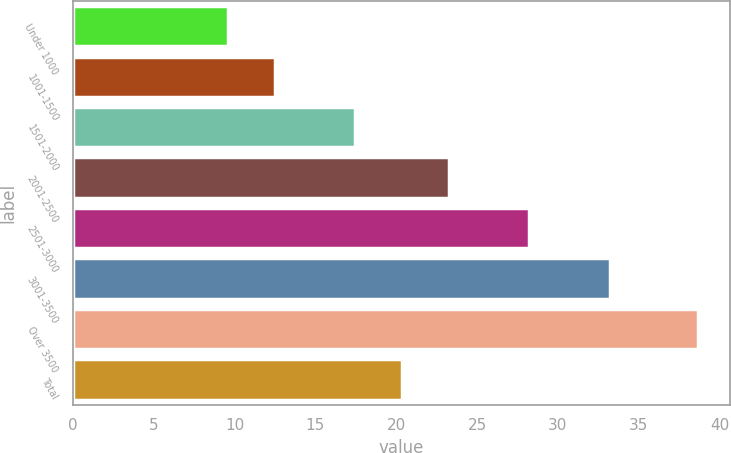Convert chart to OTSL. <chart><loc_0><loc_0><loc_500><loc_500><bar_chart><fcel>Under 1000<fcel>1001-1500<fcel>1501-2000<fcel>2001-2500<fcel>2501-3000<fcel>3001-3500<fcel>Over 3500<fcel>Total<nl><fcel>9.57<fcel>12.48<fcel>17.43<fcel>23.25<fcel>28.22<fcel>33.25<fcel>38.7<fcel>20.34<nl></chart> 